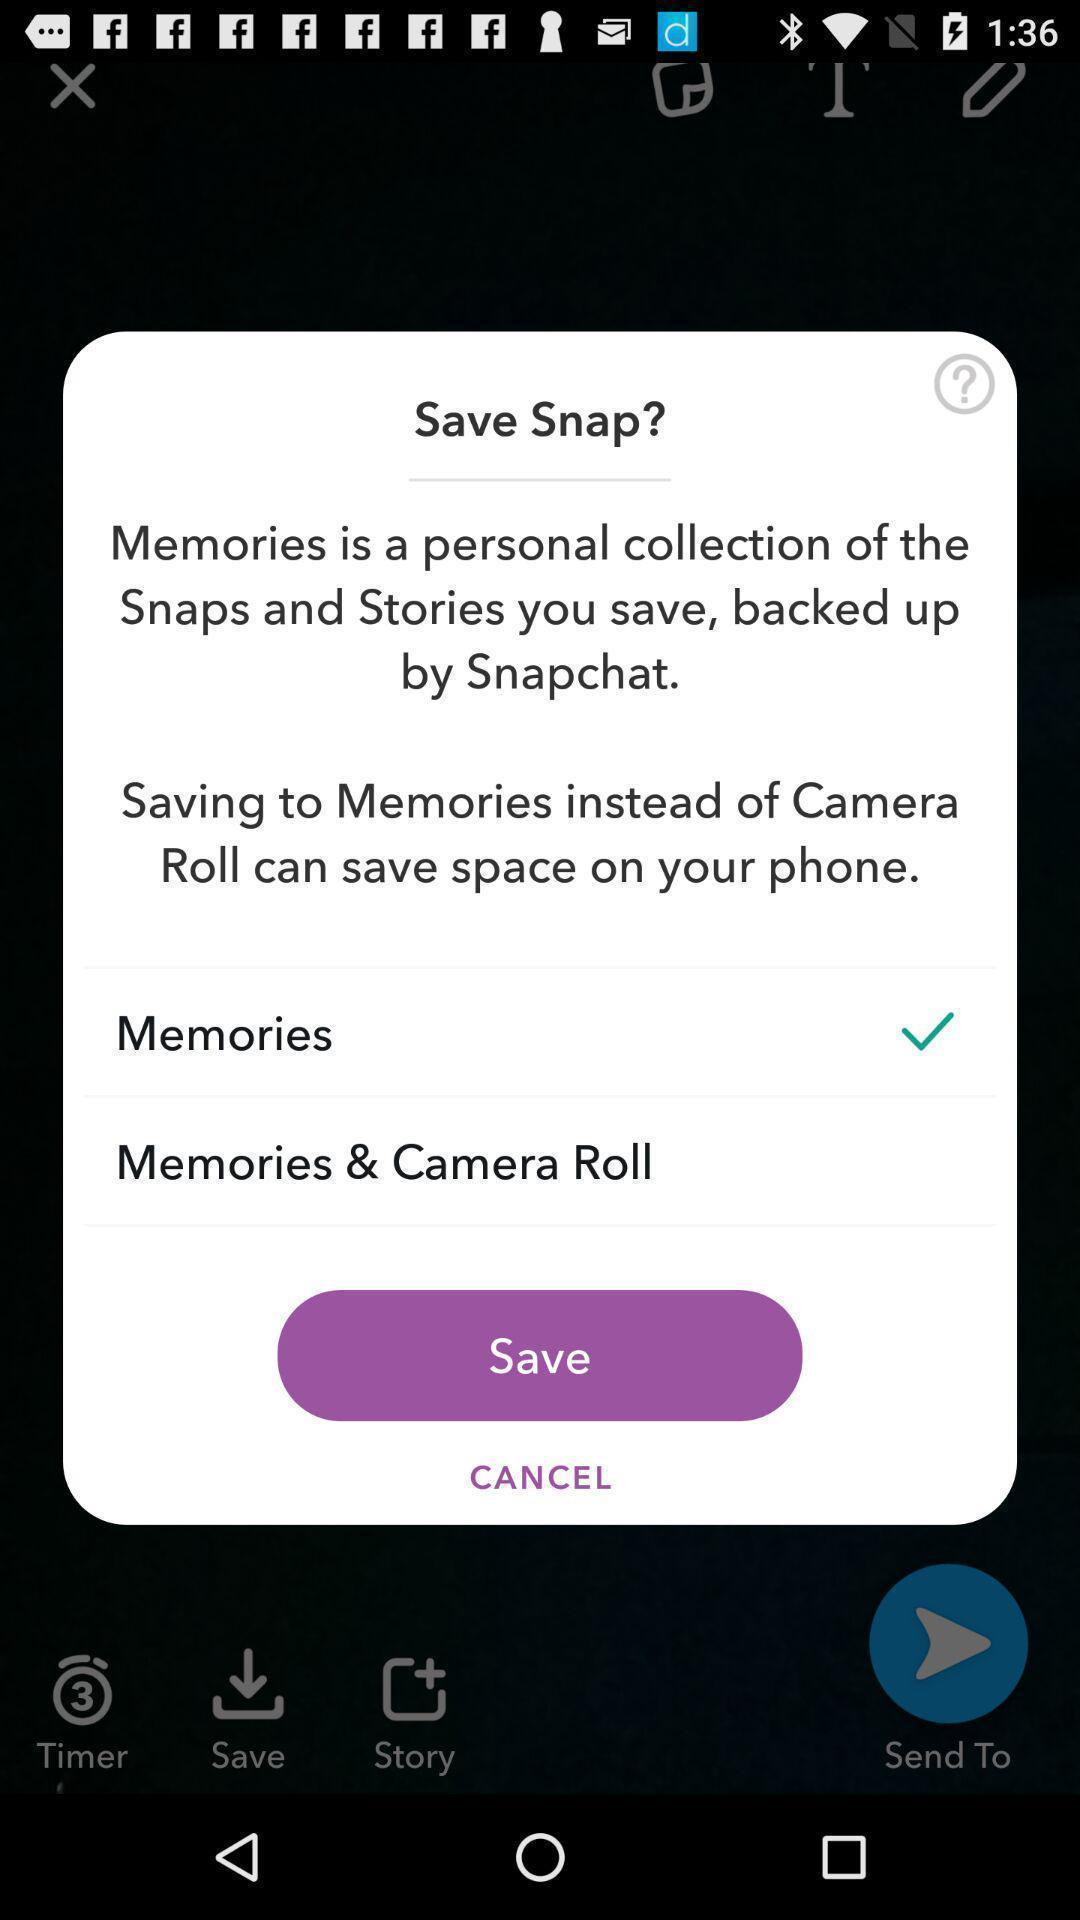Describe the key features of this screenshot. Pop-up to save the snap. 